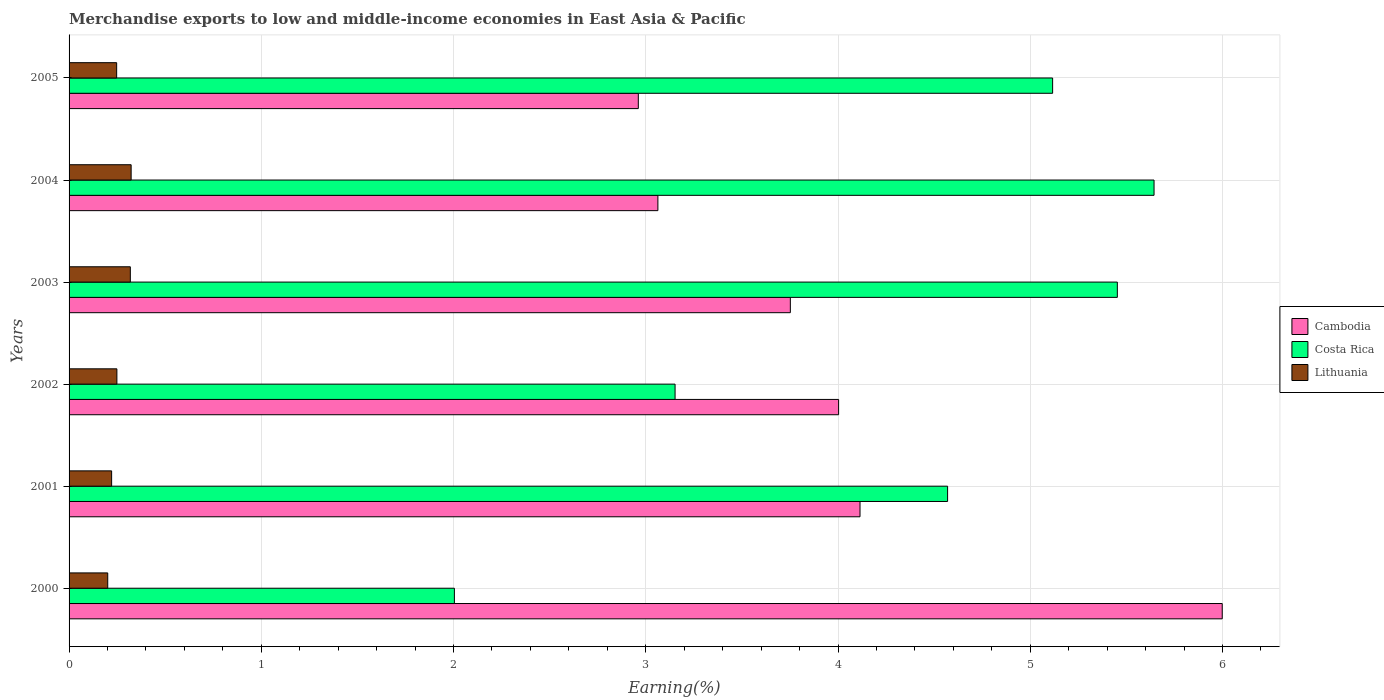How many different coloured bars are there?
Give a very brief answer. 3. How many groups of bars are there?
Make the answer very short. 6. How many bars are there on the 6th tick from the bottom?
Provide a short and direct response. 3. What is the label of the 4th group of bars from the top?
Your response must be concise. 2002. What is the percentage of amount earned from merchandise exports in Lithuania in 2002?
Provide a succinct answer. 0.25. Across all years, what is the maximum percentage of amount earned from merchandise exports in Cambodia?
Offer a terse response. 6. Across all years, what is the minimum percentage of amount earned from merchandise exports in Lithuania?
Your response must be concise. 0.2. What is the total percentage of amount earned from merchandise exports in Costa Rica in the graph?
Ensure brevity in your answer.  25.94. What is the difference between the percentage of amount earned from merchandise exports in Costa Rica in 2002 and that in 2003?
Provide a short and direct response. -2.3. What is the difference between the percentage of amount earned from merchandise exports in Costa Rica in 2001 and the percentage of amount earned from merchandise exports in Cambodia in 2002?
Give a very brief answer. 0.57. What is the average percentage of amount earned from merchandise exports in Lithuania per year?
Your answer should be very brief. 0.26. In the year 2002, what is the difference between the percentage of amount earned from merchandise exports in Lithuania and percentage of amount earned from merchandise exports in Cambodia?
Ensure brevity in your answer.  -3.75. In how many years, is the percentage of amount earned from merchandise exports in Cambodia greater than 1.6 %?
Your response must be concise. 6. What is the ratio of the percentage of amount earned from merchandise exports in Lithuania in 2002 to that in 2004?
Give a very brief answer. 0.77. Is the difference between the percentage of amount earned from merchandise exports in Lithuania in 2002 and 2005 greater than the difference between the percentage of amount earned from merchandise exports in Cambodia in 2002 and 2005?
Offer a terse response. No. What is the difference between the highest and the second highest percentage of amount earned from merchandise exports in Costa Rica?
Ensure brevity in your answer.  0.19. What is the difference between the highest and the lowest percentage of amount earned from merchandise exports in Cambodia?
Provide a succinct answer. 3.04. In how many years, is the percentage of amount earned from merchandise exports in Lithuania greater than the average percentage of amount earned from merchandise exports in Lithuania taken over all years?
Provide a succinct answer. 2. What does the 1st bar from the top in 2001 represents?
Keep it short and to the point. Lithuania. What does the 3rd bar from the bottom in 2004 represents?
Give a very brief answer. Lithuania. How many years are there in the graph?
Your answer should be compact. 6. Does the graph contain any zero values?
Provide a short and direct response. No. What is the title of the graph?
Provide a succinct answer. Merchandise exports to low and middle-income economies in East Asia & Pacific. Does "Ukraine" appear as one of the legend labels in the graph?
Provide a succinct answer. No. What is the label or title of the X-axis?
Provide a succinct answer. Earning(%). What is the Earning(%) of Cambodia in 2000?
Your answer should be compact. 6. What is the Earning(%) of Costa Rica in 2000?
Your response must be concise. 2. What is the Earning(%) of Lithuania in 2000?
Keep it short and to the point. 0.2. What is the Earning(%) in Cambodia in 2001?
Provide a short and direct response. 4.11. What is the Earning(%) in Costa Rica in 2001?
Give a very brief answer. 4.57. What is the Earning(%) of Lithuania in 2001?
Offer a terse response. 0.22. What is the Earning(%) in Cambodia in 2002?
Your response must be concise. 4. What is the Earning(%) of Costa Rica in 2002?
Keep it short and to the point. 3.15. What is the Earning(%) in Lithuania in 2002?
Ensure brevity in your answer.  0.25. What is the Earning(%) of Cambodia in 2003?
Offer a terse response. 3.75. What is the Earning(%) in Costa Rica in 2003?
Give a very brief answer. 5.45. What is the Earning(%) in Lithuania in 2003?
Keep it short and to the point. 0.32. What is the Earning(%) of Cambodia in 2004?
Offer a terse response. 3.06. What is the Earning(%) of Costa Rica in 2004?
Provide a short and direct response. 5.64. What is the Earning(%) of Lithuania in 2004?
Your answer should be compact. 0.32. What is the Earning(%) of Cambodia in 2005?
Make the answer very short. 2.96. What is the Earning(%) in Costa Rica in 2005?
Keep it short and to the point. 5.12. What is the Earning(%) of Lithuania in 2005?
Give a very brief answer. 0.25. Across all years, what is the maximum Earning(%) in Cambodia?
Keep it short and to the point. 6. Across all years, what is the maximum Earning(%) of Costa Rica?
Provide a short and direct response. 5.64. Across all years, what is the maximum Earning(%) in Lithuania?
Your response must be concise. 0.32. Across all years, what is the minimum Earning(%) in Cambodia?
Provide a succinct answer. 2.96. Across all years, what is the minimum Earning(%) of Costa Rica?
Ensure brevity in your answer.  2. Across all years, what is the minimum Earning(%) in Lithuania?
Your answer should be compact. 0.2. What is the total Earning(%) in Cambodia in the graph?
Make the answer very short. 23.89. What is the total Earning(%) of Costa Rica in the graph?
Your response must be concise. 25.94. What is the total Earning(%) in Lithuania in the graph?
Give a very brief answer. 1.56. What is the difference between the Earning(%) of Cambodia in 2000 and that in 2001?
Offer a very short reply. 1.88. What is the difference between the Earning(%) of Costa Rica in 2000 and that in 2001?
Offer a very short reply. -2.57. What is the difference between the Earning(%) of Lithuania in 2000 and that in 2001?
Offer a very short reply. -0.02. What is the difference between the Earning(%) of Cambodia in 2000 and that in 2002?
Your answer should be very brief. 2. What is the difference between the Earning(%) in Costa Rica in 2000 and that in 2002?
Make the answer very short. -1.15. What is the difference between the Earning(%) of Lithuania in 2000 and that in 2002?
Ensure brevity in your answer.  -0.05. What is the difference between the Earning(%) of Cambodia in 2000 and that in 2003?
Provide a short and direct response. 2.25. What is the difference between the Earning(%) in Costa Rica in 2000 and that in 2003?
Ensure brevity in your answer.  -3.45. What is the difference between the Earning(%) in Lithuania in 2000 and that in 2003?
Your answer should be compact. -0.12. What is the difference between the Earning(%) of Cambodia in 2000 and that in 2004?
Ensure brevity in your answer.  2.94. What is the difference between the Earning(%) of Costa Rica in 2000 and that in 2004?
Provide a succinct answer. -3.64. What is the difference between the Earning(%) of Lithuania in 2000 and that in 2004?
Provide a short and direct response. -0.12. What is the difference between the Earning(%) of Cambodia in 2000 and that in 2005?
Provide a succinct answer. 3.04. What is the difference between the Earning(%) of Costa Rica in 2000 and that in 2005?
Ensure brevity in your answer.  -3.11. What is the difference between the Earning(%) of Lithuania in 2000 and that in 2005?
Offer a very short reply. -0.05. What is the difference between the Earning(%) of Cambodia in 2001 and that in 2002?
Keep it short and to the point. 0.11. What is the difference between the Earning(%) in Costa Rica in 2001 and that in 2002?
Make the answer very short. 1.42. What is the difference between the Earning(%) of Lithuania in 2001 and that in 2002?
Your response must be concise. -0.03. What is the difference between the Earning(%) of Cambodia in 2001 and that in 2003?
Ensure brevity in your answer.  0.36. What is the difference between the Earning(%) of Costa Rica in 2001 and that in 2003?
Your answer should be very brief. -0.88. What is the difference between the Earning(%) in Lithuania in 2001 and that in 2003?
Give a very brief answer. -0.1. What is the difference between the Earning(%) of Cambodia in 2001 and that in 2004?
Your response must be concise. 1.05. What is the difference between the Earning(%) of Costa Rica in 2001 and that in 2004?
Keep it short and to the point. -1.07. What is the difference between the Earning(%) of Lithuania in 2001 and that in 2004?
Your answer should be very brief. -0.1. What is the difference between the Earning(%) of Cambodia in 2001 and that in 2005?
Your answer should be very brief. 1.15. What is the difference between the Earning(%) of Costa Rica in 2001 and that in 2005?
Offer a very short reply. -0.55. What is the difference between the Earning(%) in Lithuania in 2001 and that in 2005?
Your answer should be compact. -0.03. What is the difference between the Earning(%) of Cambodia in 2002 and that in 2003?
Your answer should be very brief. 0.25. What is the difference between the Earning(%) of Costa Rica in 2002 and that in 2003?
Ensure brevity in your answer.  -2.3. What is the difference between the Earning(%) in Lithuania in 2002 and that in 2003?
Your answer should be very brief. -0.07. What is the difference between the Earning(%) in Cambodia in 2002 and that in 2004?
Make the answer very short. 0.94. What is the difference between the Earning(%) of Costa Rica in 2002 and that in 2004?
Keep it short and to the point. -2.49. What is the difference between the Earning(%) of Lithuania in 2002 and that in 2004?
Provide a short and direct response. -0.07. What is the difference between the Earning(%) in Cambodia in 2002 and that in 2005?
Provide a succinct answer. 1.04. What is the difference between the Earning(%) in Costa Rica in 2002 and that in 2005?
Make the answer very short. -1.96. What is the difference between the Earning(%) of Lithuania in 2002 and that in 2005?
Your answer should be compact. 0. What is the difference between the Earning(%) of Cambodia in 2003 and that in 2004?
Offer a very short reply. 0.69. What is the difference between the Earning(%) of Costa Rica in 2003 and that in 2004?
Your answer should be compact. -0.19. What is the difference between the Earning(%) in Lithuania in 2003 and that in 2004?
Provide a succinct answer. -0. What is the difference between the Earning(%) of Cambodia in 2003 and that in 2005?
Make the answer very short. 0.79. What is the difference between the Earning(%) in Costa Rica in 2003 and that in 2005?
Give a very brief answer. 0.34. What is the difference between the Earning(%) of Lithuania in 2003 and that in 2005?
Offer a terse response. 0.07. What is the difference between the Earning(%) of Cambodia in 2004 and that in 2005?
Offer a terse response. 0.1. What is the difference between the Earning(%) of Costa Rica in 2004 and that in 2005?
Offer a very short reply. 0.53. What is the difference between the Earning(%) of Lithuania in 2004 and that in 2005?
Ensure brevity in your answer.  0.08. What is the difference between the Earning(%) of Cambodia in 2000 and the Earning(%) of Costa Rica in 2001?
Your answer should be compact. 1.43. What is the difference between the Earning(%) of Cambodia in 2000 and the Earning(%) of Lithuania in 2001?
Your response must be concise. 5.78. What is the difference between the Earning(%) of Costa Rica in 2000 and the Earning(%) of Lithuania in 2001?
Your answer should be compact. 1.78. What is the difference between the Earning(%) of Cambodia in 2000 and the Earning(%) of Costa Rica in 2002?
Provide a succinct answer. 2.85. What is the difference between the Earning(%) in Cambodia in 2000 and the Earning(%) in Lithuania in 2002?
Provide a short and direct response. 5.75. What is the difference between the Earning(%) of Costa Rica in 2000 and the Earning(%) of Lithuania in 2002?
Your answer should be very brief. 1.76. What is the difference between the Earning(%) in Cambodia in 2000 and the Earning(%) in Costa Rica in 2003?
Make the answer very short. 0.55. What is the difference between the Earning(%) of Cambodia in 2000 and the Earning(%) of Lithuania in 2003?
Your answer should be compact. 5.68. What is the difference between the Earning(%) of Costa Rica in 2000 and the Earning(%) of Lithuania in 2003?
Your answer should be compact. 1.69. What is the difference between the Earning(%) of Cambodia in 2000 and the Earning(%) of Costa Rica in 2004?
Offer a very short reply. 0.35. What is the difference between the Earning(%) in Cambodia in 2000 and the Earning(%) in Lithuania in 2004?
Provide a short and direct response. 5.68. What is the difference between the Earning(%) of Costa Rica in 2000 and the Earning(%) of Lithuania in 2004?
Your answer should be compact. 1.68. What is the difference between the Earning(%) in Cambodia in 2000 and the Earning(%) in Costa Rica in 2005?
Make the answer very short. 0.88. What is the difference between the Earning(%) of Cambodia in 2000 and the Earning(%) of Lithuania in 2005?
Provide a succinct answer. 5.75. What is the difference between the Earning(%) of Costa Rica in 2000 and the Earning(%) of Lithuania in 2005?
Offer a terse response. 1.76. What is the difference between the Earning(%) in Cambodia in 2001 and the Earning(%) in Costa Rica in 2002?
Provide a succinct answer. 0.96. What is the difference between the Earning(%) in Cambodia in 2001 and the Earning(%) in Lithuania in 2002?
Offer a terse response. 3.87. What is the difference between the Earning(%) of Costa Rica in 2001 and the Earning(%) of Lithuania in 2002?
Your answer should be compact. 4.32. What is the difference between the Earning(%) in Cambodia in 2001 and the Earning(%) in Costa Rica in 2003?
Your answer should be very brief. -1.34. What is the difference between the Earning(%) of Cambodia in 2001 and the Earning(%) of Lithuania in 2003?
Your answer should be compact. 3.8. What is the difference between the Earning(%) of Costa Rica in 2001 and the Earning(%) of Lithuania in 2003?
Your answer should be very brief. 4.25. What is the difference between the Earning(%) of Cambodia in 2001 and the Earning(%) of Costa Rica in 2004?
Keep it short and to the point. -1.53. What is the difference between the Earning(%) in Cambodia in 2001 and the Earning(%) in Lithuania in 2004?
Your answer should be compact. 3.79. What is the difference between the Earning(%) of Costa Rica in 2001 and the Earning(%) of Lithuania in 2004?
Ensure brevity in your answer.  4.25. What is the difference between the Earning(%) of Cambodia in 2001 and the Earning(%) of Costa Rica in 2005?
Your answer should be very brief. -1. What is the difference between the Earning(%) of Cambodia in 2001 and the Earning(%) of Lithuania in 2005?
Provide a short and direct response. 3.87. What is the difference between the Earning(%) of Costa Rica in 2001 and the Earning(%) of Lithuania in 2005?
Provide a succinct answer. 4.32. What is the difference between the Earning(%) in Cambodia in 2002 and the Earning(%) in Costa Rica in 2003?
Your answer should be very brief. -1.45. What is the difference between the Earning(%) in Cambodia in 2002 and the Earning(%) in Lithuania in 2003?
Keep it short and to the point. 3.68. What is the difference between the Earning(%) in Costa Rica in 2002 and the Earning(%) in Lithuania in 2003?
Ensure brevity in your answer.  2.83. What is the difference between the Earning(%) in Cambodia in 2002 and the Earning(%) in Costa Rica in 2004?
Your answer should be very brief. -1.64. What is the difference between the Earning(%) in Cambodia in 2002 and the Earning(%) in Lithuania in 2004?
Offer a very short reply. 3.68. What is the difference between the Earning(%) in Costa Rica in 2002 and the Earning(%) in Lithuania in 2004?
Provide a succinct answer. 2.83. What is the difference between the Earning(%) of Cambodia in 2002 and the Earning(%) of Costa Rica in 2005?
Offer a very short reply. -1.11. What is the difference between the Earning(%) of Cambodia in 2002 and the Earning(%) of Lithuania in 2005?
Your answer should be compact. 3.76. What is the difference between the Earning(%) in Costa Rica in 2002 and the Earning(%) in Lithuania in 2005?
Provide a short and direct response. 2.9. What is the difference between the Earning(%) in Cambodia in 2003 and the Earning(%) in Costa Rica in 2004?
Offer a very short reply. -1.89. What is the difference between the Earning(%) in Cambodia in 2003 and the Earning(%) in Lithuania in 2004?
Provide a succinct answer. 3.43. What is the difference between the Earning(%) of Costa Rica in 2003 and the Earning(%) of Lithuania in 2004?
Your answer should be very brief. 5.13. What is the difference between the Earning(%) of Cambodia in 2003 and the Earning(%) of Costa Rica in 2005?
Give a very brief answer. -1.36. What is the difference between the Earning(%) of Cambodia in 2003 and the Earning(%) of Lithuania in 2005?
Provide a succinct answer. 3.5. What is the difference between the Earning(%) in Costa Rica in 2003 and the Earning(%) in Lithuania in 2005?
Ensure brevity in your answer.  5.21. What is the difference between the Earning(%) of Cambodia in 2004 and the Earning(%) of Costa Rica in 2005?
Your answer should be very brief. -2.05. What is the difference between the Earning(%) in Cambodia in 2004 and the Earning(%) in Lithuania in 2005?
Your answer should be very brief. 2.82. What is the difference between the Earning(%) in Costa Rica in 2004 and the Earning(%) in Lithuania in 2005?
Your answer should be compact. 5.4. What is the average Earning(%) in Cambodia per year?
Your answer should be very brief. 3.98. What is the average Earning(%) in Costa Rica per year?
Your answer should be compact. 4.32. What is the average Earning(%) of Lithuania per year?
Your response must be concise. 0.26. In the year 2000, what is the difference between the Earning(%) in Cambodia and Earning(%) in Costa Rica?
Provide a succinct answer. 3.99. In the year 2000, what is the difference between the Earning(%) of Cambodia and Earning(%) of Lithuania?
Keep it short and to the point. 5.8. In the year 2000, what is the difference between the Earning(%) of Costa Rica and Earning(%) of Lithuania?
Offer a very short reply. 1.8. In the year 2001, what is the difference between the Earning(%) of Cambodia and Earning(%) of Costa Rica?
Offer a terse response. -0.46. In the year 2001, what is the difference between the Earning(%) of Cambodia and Earning(%) of Lithuania?
Offer a very short reply. 3.89. In the year 2001, what is the difference between the Earning(%) in Costa Rica and Earning(%) in Lithuania?
Offer a terse response. 4.35. In the year 2002, what is the difference between the Earning(%) in Cambodia and Earning(%) in Costa Rica?
Offer a very short reply. 0.85. In the year 2002, what is the difference between the Earning(%) of Cambodia and Earning(%) of Lithuania?
Keep it short and to the point. 3.75. In the year 2002, what is the difference between the Earning(%) of Costa Rica and Earning(%) of Lithuania?
Provide a short and direct response. 2.9. In the year 2003, what is the difference between the Earning(%) of Cambodia and Earning(%) of Costa Rica?
Your answer should be compact. -1.7. In the year 2003, what is the difference between the Earning(%) of Cambodia and Earning(%) of Lithuania?
Keep it short and to the point. 3.43. In the year 2003, what is the difference between the Earning(%) in Costa Rica and Earning(%) in Lithuania?
Your answer should be very brief. 5.13. In the year 2004, what is the difference between the Earning(%) of Cambodia and Earning(%) of Costa Rica?
Your answer should be very brief. -2.58. In the year 2004, what is the difference between the Earning(%) in Cambodia and Earning(%) in Lithuania?
Your answer should be very brief. 2.74. In the year 2004, what is the difference between the Earning(%) in Costa Rica and Earning(%) in Lithuania?
Ensure brevity in your answer.  5.32. In the year 2005, what is the difference between the Earning(%) in Cambodia and Earning(%) in Costa Rica?
Make the answer very short. -2.16. In the year 2005, what is the difference between the Earning(%) in Cambodia and Earning(%) in Lithuania?
Your response must be concise. 2.71. In the year 2005, what is the difference between the Earning(%) of Costa Rica and Earning(%) of Lithuania?
Provide a succinct answer. 4.87. What is the ratio of the Earning(%) in Cambodia in 2000 to that in 2001?
Provide a short and direct response. 1.46. What is the ratio of the Earning(%) of Costa Rica in 2000 to that in 2001?
Keep it short and to the point. 0.44. What is the ratio of the Earning(%) of Lithuania in 2000 to that in 2001?
Provide a succinct answer. 0.91. What is the ratio of the Earning(%) of Cambodia in 2000 to that in 2002?
Provide a succinct answer. 1.5. What is the ratio of the Earning(%) of Costa Rica in 2000 to that in 2002?
Make the answer very short. 0.64. What is the ratio of the Earning(%) in Lithuania in 2000 to that in 2002?
Ensure brevity in your answer.  0.81. What is the ratio of the Earning(%) of Cambodia in 2000 to that in 2003?
Your answer should be very brief. 1.6. What is the ratio of the Earning(%) in Costa Rica in 2000 to that in 2003?
Your answer should be very brief. 0.37. What is the ratio of the Earning(%) in Lithuania in 2000 to that in 2003?
Keep it short and to the point. 0.63. What is the ratio of the Earning(%) of Cambodia in 2000 to that in 2004?
Give a very brief answer. 1.96. What is the ratio of the Earning(%) of Costa Rica in 2000 to that in 2004?
Your response must be concise. 0.36. What is the ratio of the Earning(%) in Lithuania in 2000 to that in 2004?
Provide a short and direct response. 0.62. What is the ratio of the Earning(%) in Cambodia in 2000 to that in 2005?
Offer a very short reply. 2.03. What is the ratio of the Earning(%) of Costa Rica in 2000 to that in 2005?
Offer a very short reply. 0.39. What is the ratio of the Earning(%) in Lithuania in 2000 to that in 2005?
Make the answer very short. 0.81. What is the ratio of the Earning(%) in Cambodia in 2001 to that in 2002?
Offer a terse response. 1.03. What is the ratio of the Earning(%) of Costa Rica in 2001 to that in 2002?
Your response must be concise. 1.45. What is the ratio of the Earning(%) of Lithuania in 2001 to that in 2002?
Offer a very short reply. 0.89. What is the ratio of the Earning(%) in Cambodia in 2001 to that in 2003?
Make the answer very short. 1.1. What is the ratio of the Earning(%) of Costa Rica in 2001 to that in 2003?
Offer a terse response. 0.84. What is the ratio of the Earning(%) in Lithuania in 2001 to that in 2003?
Keep it short and to the point. 0.69. What is the ratio of the Earning(%) of Cambodia in 2001 to that in 2004?
Ensure brevity in your answer.  1.34. What is the ratio of the Earning(%) in Costa Rica in 2001 to that in 2004?
Ensure brevity in your answer.  0.81. What is the ratio of the Earning(%) of Lithuania in 2001 to that in 2004?
Ensure brevity in your answer.  0.69. What is the ratio of the Earning(%) in Cambodia in 2001 to that in 2005?
Keep it short and to the point. 1.39. What is the ratio of the Earning(%) in Costa Rica in 2001 to that in 2005?
Give a very brief answer. 0.89. What is the ratio of the Earning(%) in Lithuania in 2001 to that in 2005?
Give a very brief answer. 0.89. What is the ratio of the Earning(%) in Cambodia in 2002 to that in 2003?
Offer a very short reply. 1.07. What is the ratio of the Earning(%) of Costa Rica in 2002 to that in 2003?
Make the answer very short. 0.58. What is the ratio of the Earning(%) in Lithuania in 2002 to that in 2003?
Give a very brief answer. 0.78. What is the ratio of the Earning(%) in Cambodia in 2002 to that in 2004?
Your answer should be compact. 1.31. What is the ratio of the Earning(%) of Costa Rica in 2002 to that in 2004?
Offer a terse response. 0.56. What is the ratio of the Earning(%) of Lithuania in 2002 to that in 2004?
Make the answer very short. 0.77. What is the ratio of the Earning(%) of Cambodia in 2002 to that in 2005?
Provide a short and direct response. 1.35. What is the ratio of the Earning(%) in Costa Rica in 2002 to that in 2005?
Provide a succinct answer. 0.62. What is the ratio of the Earning(%) in Lithuania in 2002 to that in 2005?
Ensure brevity in your answer.  1. What is the ratio of the Earning(%) in Cambodia in 2003 to that in 2004?
Ensure brevity in your answer.  1.22. What is the ratio of the Earning(%) in Costa Rica in 2003 to that in 2004?
Provide a short and direct response. 0.97. What is the ratio of the Earning(%) of Lithuania in 2003 to that in 2004?
Offer a very short reply. 0.99. What is the ratio of the Earning(%) of Cambodia in 2003 to that in 2005?
Offer a very short reply. 1.27. What is the ratio of the Earning(%) in Costa Rica in 2003 to that in 2005?
Make the answer very short. 1.07. What is the ratio of the Earning(%) of Lithuania in 2003 to that in 2005?
Make the answer very short. 1.29. What is the ratio of the Earning(%) of Cambodia in 2004 to that in 2005?
Your answer should be very brief. 1.03. What is the ratio of the Earning(%) in Costa Rica in 2004 to that in 2005?
Offer a terse response. 1.1. What is the ratio of the Earning(%) in Lithuania in 2004 to that in 2005?
Provide a succinct answer. 1.3. What is the difference between the highest and the second highest Earning(%) in Cambodia?
Offer a very short reply. 1.88. What is the difference between the highest and the second highest Earning(%) of Costa Rica?
Provide a succinct answer. 0.19. What is the difference between the highest and the second highest Earning(%) in Lithuania?
Make the answer very short. 0. What is the difference between the highest and the lowest Earning(%) of Cambodia?
Offer a very short reply. 3.04. What is the difference between the highest and the lowest Earning(%) of Costa Rica?
Ensure brevity in your answer.  3.64. What is the difference between the highest and the lowest Earning(%) of Lithuania?
Offer a very short reply. 0.12. 